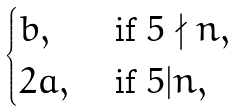<formula> <loc_0><loc_0><loc_500><loc_500>\begin{cases} b , & \text { if } 5 \nmid n , \\ 2 a , & \text { if } 5 | n , \end{cases}</formula> 